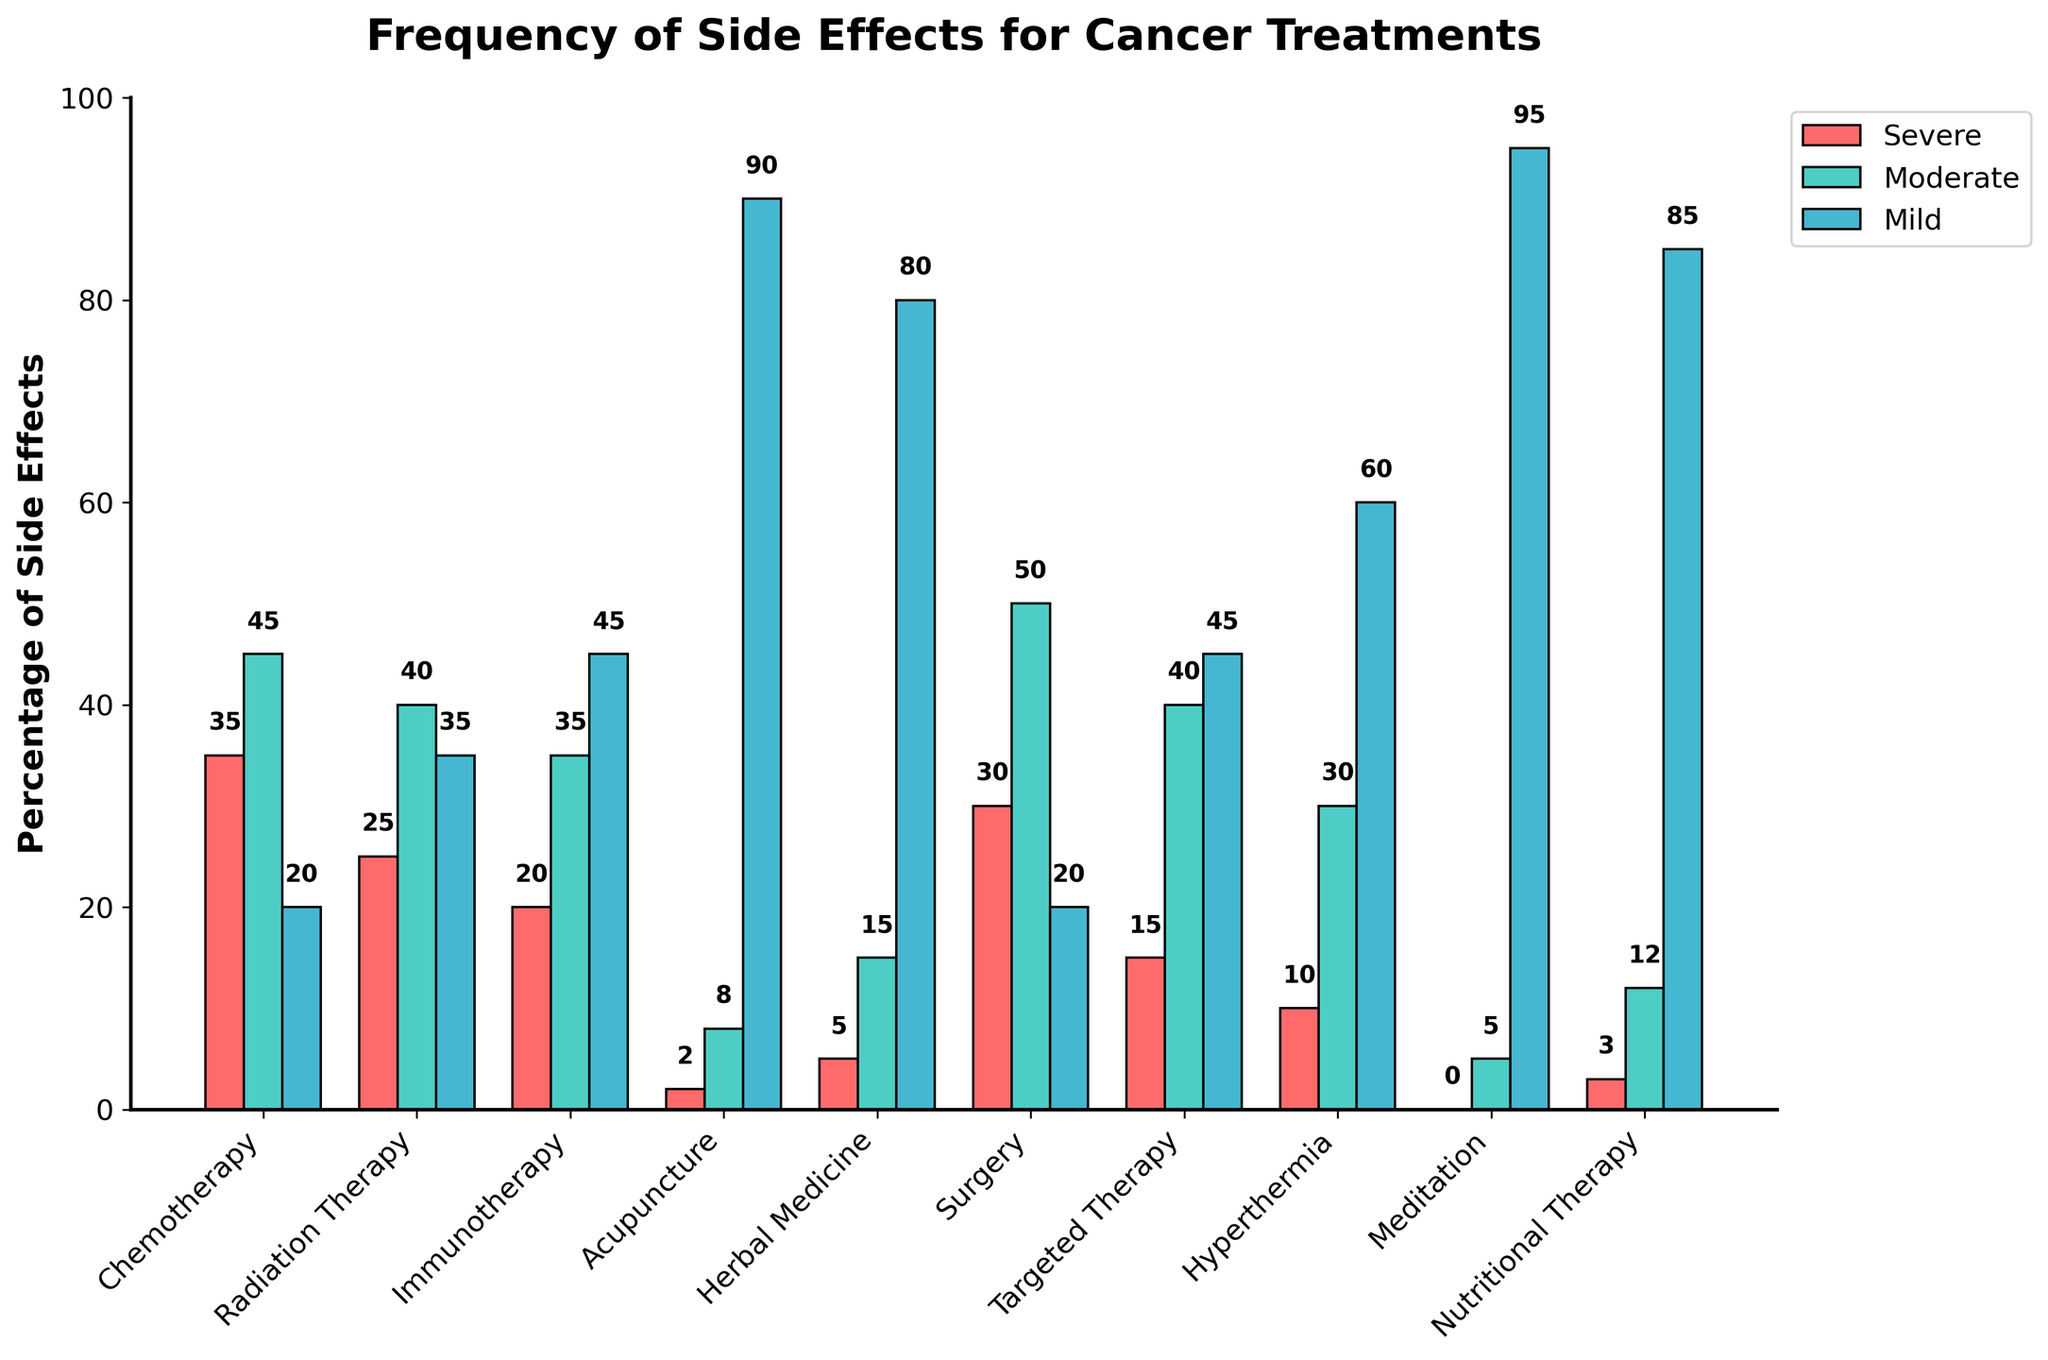What's the treatment with the highest percentage of severe side effects? Look for the bar representing 'Severe Side Effects' and identify the tallest one. Chemotherapy has the tallest red bar for severe side effects at 35%.
Answer: Chemotherapy What's the treatment with the lowest percentage of mild side effects? Locate the bars representing 'Mild Side Effects'. Meditation has the shortest blue bar for mild side effects at 95%.
Answer: Meditation What's the total percentage of side effects for Surgery? Sum the 'Severe Side Effects', 'Moderate Side Effects', and 'Mild Side Effects' for Surgery. The bars show 30%, 50%, and 20% respectively, so the total is 30 + 50 + 20 = 100%.
Answer: 100% Compare the percentage of moderate side effects between Radiation Therapy and Immunotherapy. Which one is higher? Compare the heights of the green bars for Radiation Therapy (40%) and Immunotherapy (35%).
Answer: Radiation Therapy Which treatment has equal percentages for severe and mild side effects? Look for a treatment where the red and blue bars are of the same height. Both Chemotherapy and Surgery have severe and mild side effects at 20%. However, the percentages aren't equal; the only close match is Immunotherapy for severe at 20% but higher for mild at 45%. None is perfectly equal.
Answer: None What’s the average percentage of mild side effects for the alternative treatments presented? Sum the 'Mild Side Effects' percentages for Acupuncture (90%), Herbal Medicine (80%), Meditation (95%), and Nutritional Therapy (85%). Calculate the average: (90 + 80 + 95 + 85) / 4 = 87.5%.
Answer: 87.5% How much higher is the percentage of severe side effects in Chemotherapy compared to Acupuncture? Subtract the percentage of 'Severe Side Effects' in Acupuncture (2%) from Chemotherapy (35%). The difference is 35 - 2 = 33%.
Answer: 33% What is the range of moderate side effects among the treatments? Identify the highest and lowest percentages for 'Moderate Side Effects'. The highest is Surgery (50%) and the lowest is Meditation (5%), so the range is 50 - 5 = 45%.
Answer: 45% Which treatment has a larger percentage of severe side effects than mild side effects? Look for a treatment where the red bar is taller than the blue bar. Chemotherapy (35% severe vs. 20% mild) satisfies this condition.
Answer: Chemotherapy How many alternative treatments exceed 80% mild side effects? Identify the number of treatments with 'Mild Side Effects' percentages over 80%. Acupuncture (90%), Herbal Medicine (80%), and Meditation (95%) exceed 80%.
Answer: 3 